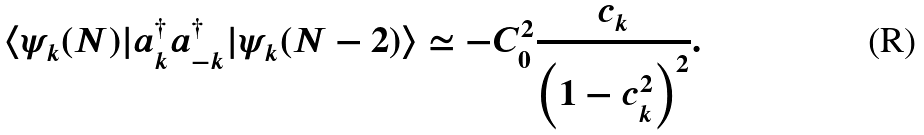<formula> <loc_0><loc_0><loc_500><loc_500>\langle \psi _ { k } ( N ) | a _ { k } ^ { \dagger } a _ { - k } ^ { \dagger } | \psi _ { k } ( N - 2 ) \rangle \simeq - C _ { 0 } ^ { 2 } \frac { c _ { k } } { \left ( 1 - c _ { k } ^ { 2 } \right ) ^ { 2 } } .</formula> 